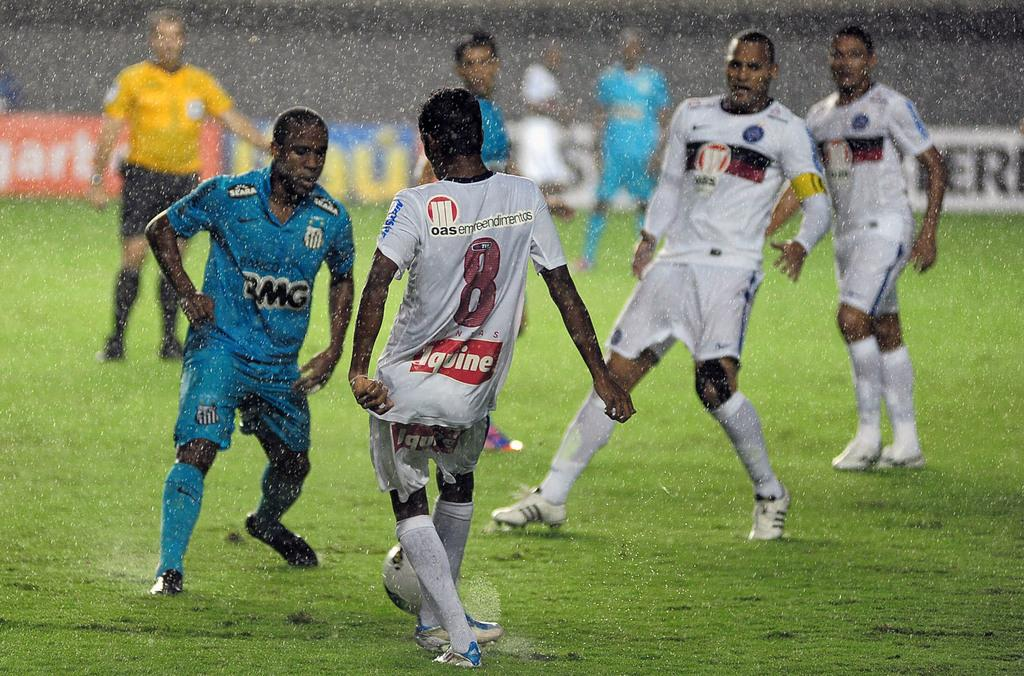What are the people in the image doing? There are players in the image, which suggests they are engaged in a game or sport. What is the main object in the center of the image? There is a ball in the center of the image. What can be seen in the background of the image? There is a banner and grass in the background of the image. What type of glass is being used to play the game in the image? There is no glass present in the image; it features players and a ball on a grassy surface. Where is the stage located in the image? There is: There is no stage present in the image; it features players and a ball on a grassy surface. 